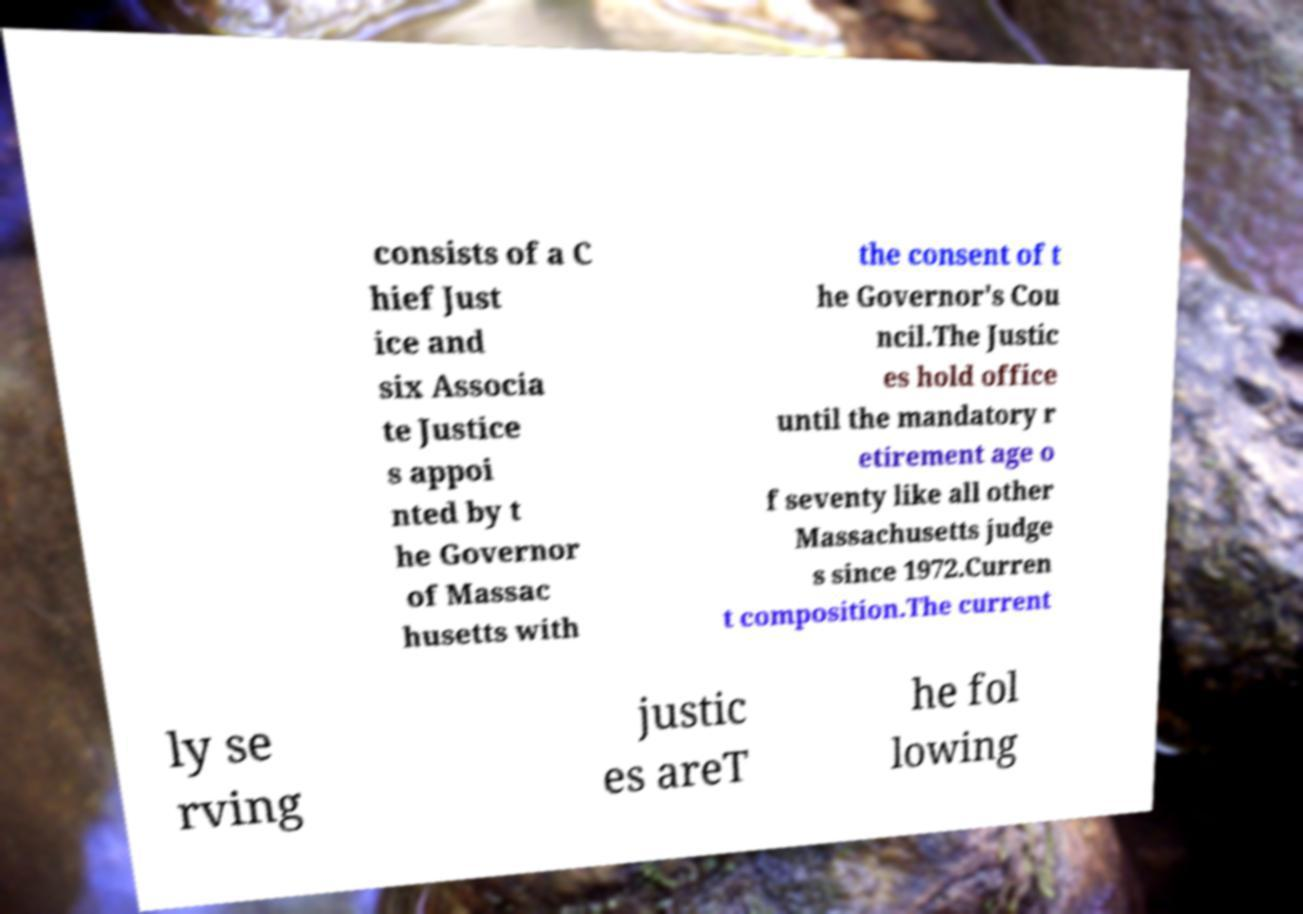Could you extract and type out the text from this image? consists of a C hief Just ice and six Associa te Justice s appoi nted by t he Governor of Massac husetts with the consent of t he Governor's Cou ncil.The Justic es hold office until the mandatory r etirement age o f seventy like all other Massachusetts judge s since 1972.Curren t composition.The current ly se rving justic es areT he fol lowing 